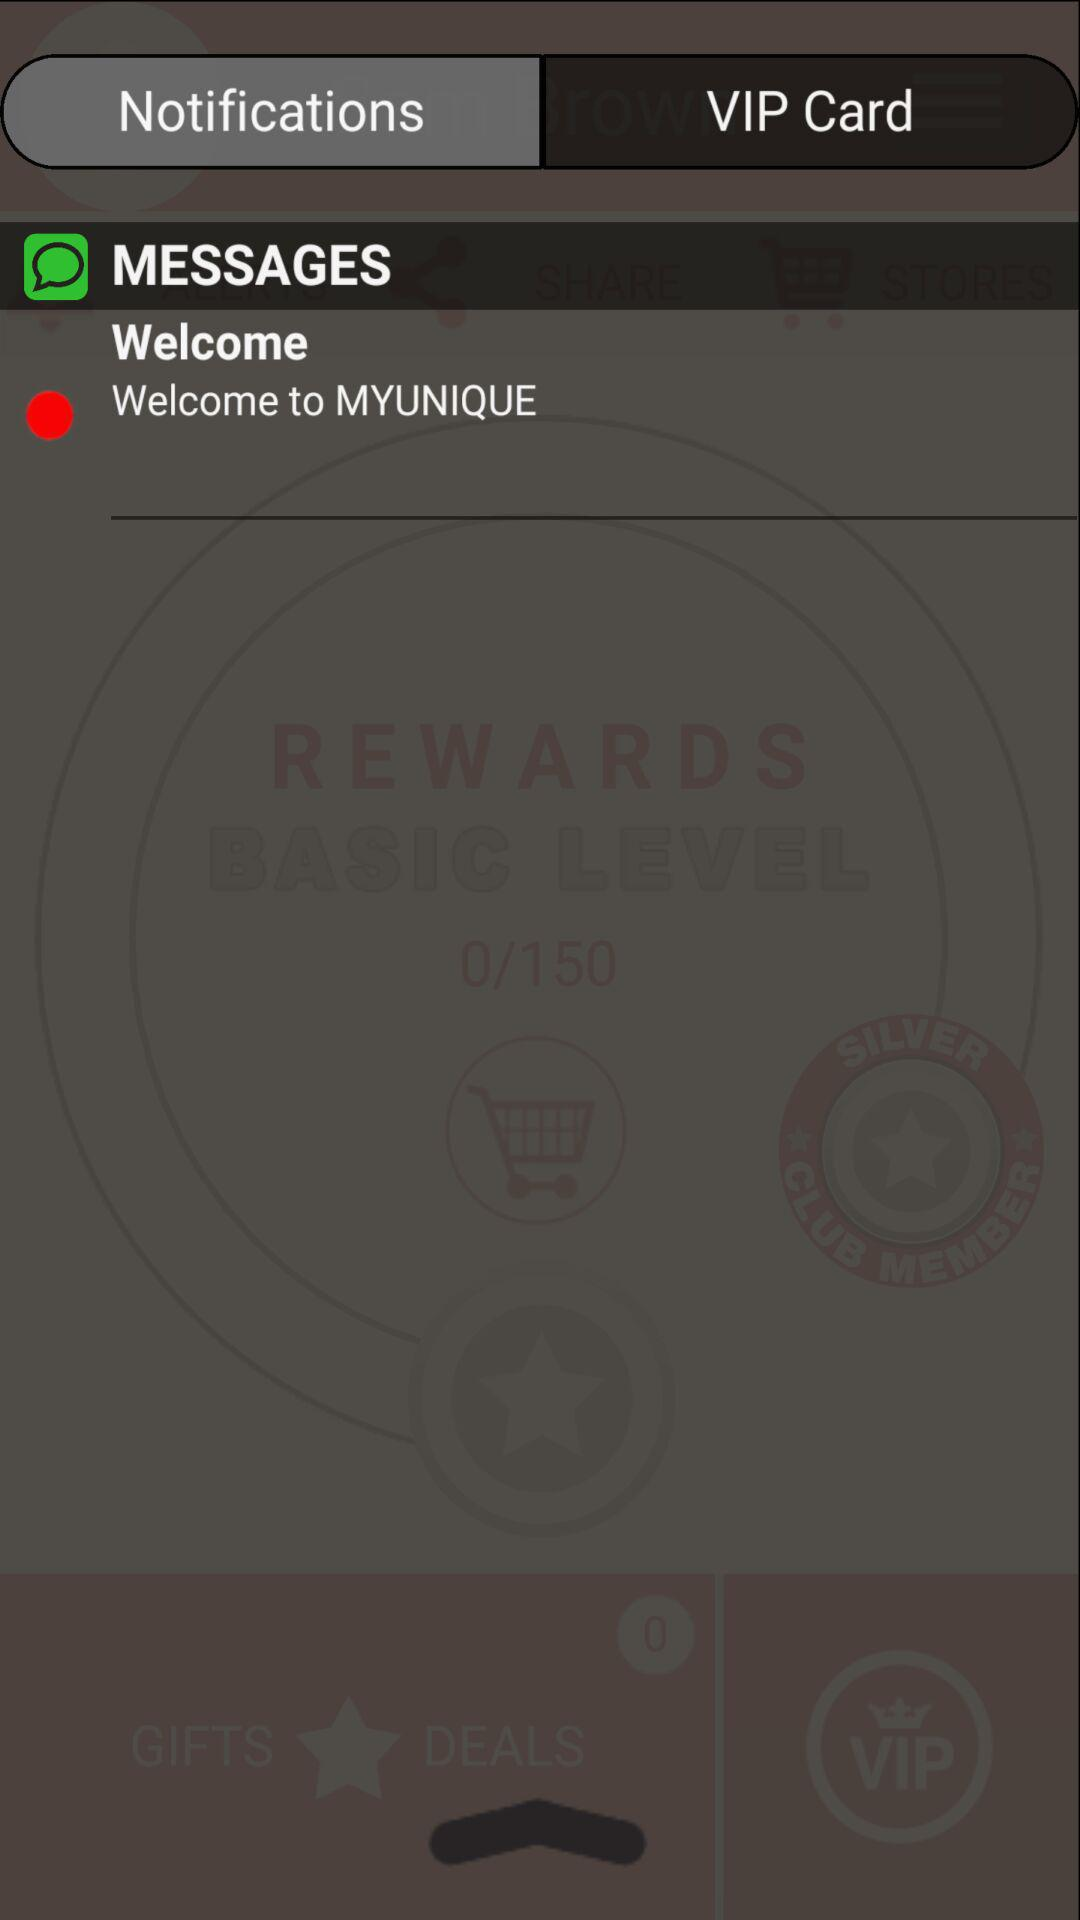Which tab is selected? The selected tab is "Notifications". 